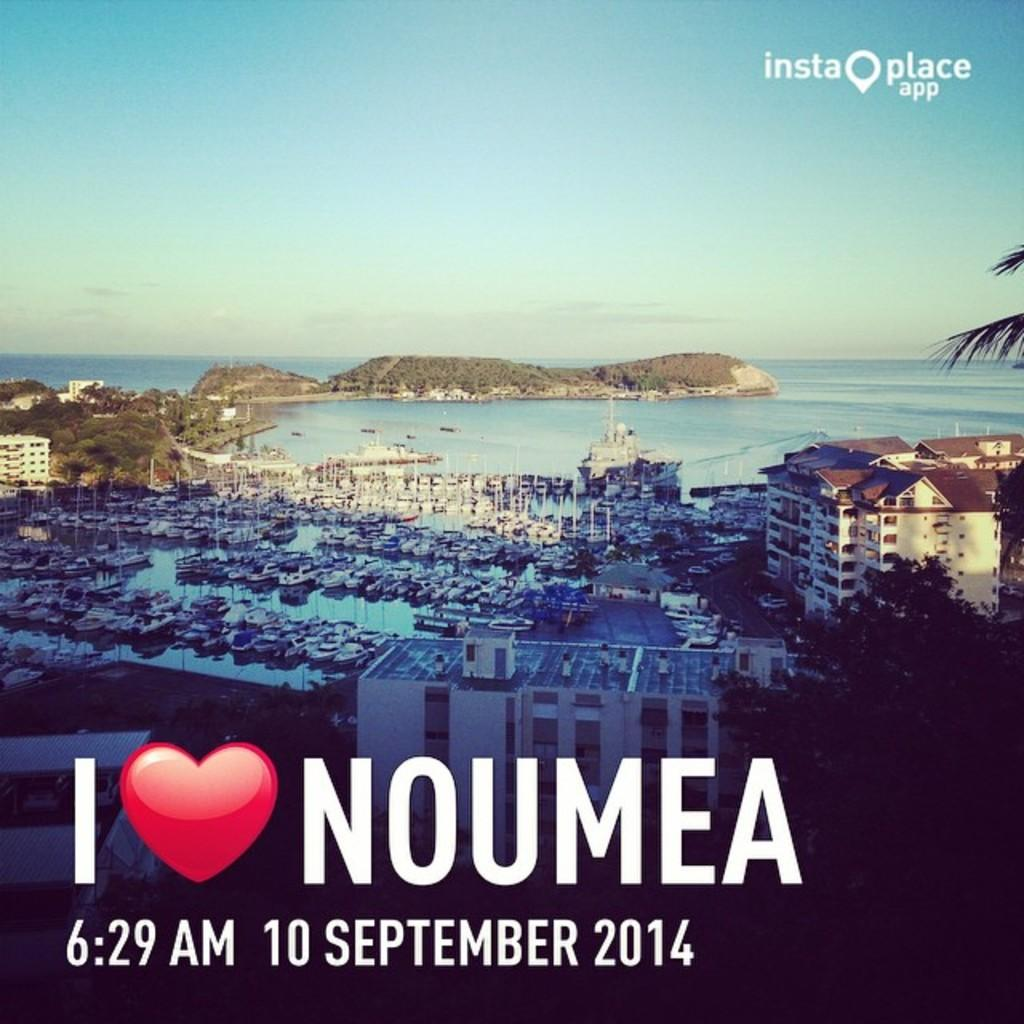Provide a one-sentence caption for the provided image. I love Noumea insta place app that have the time and date. 